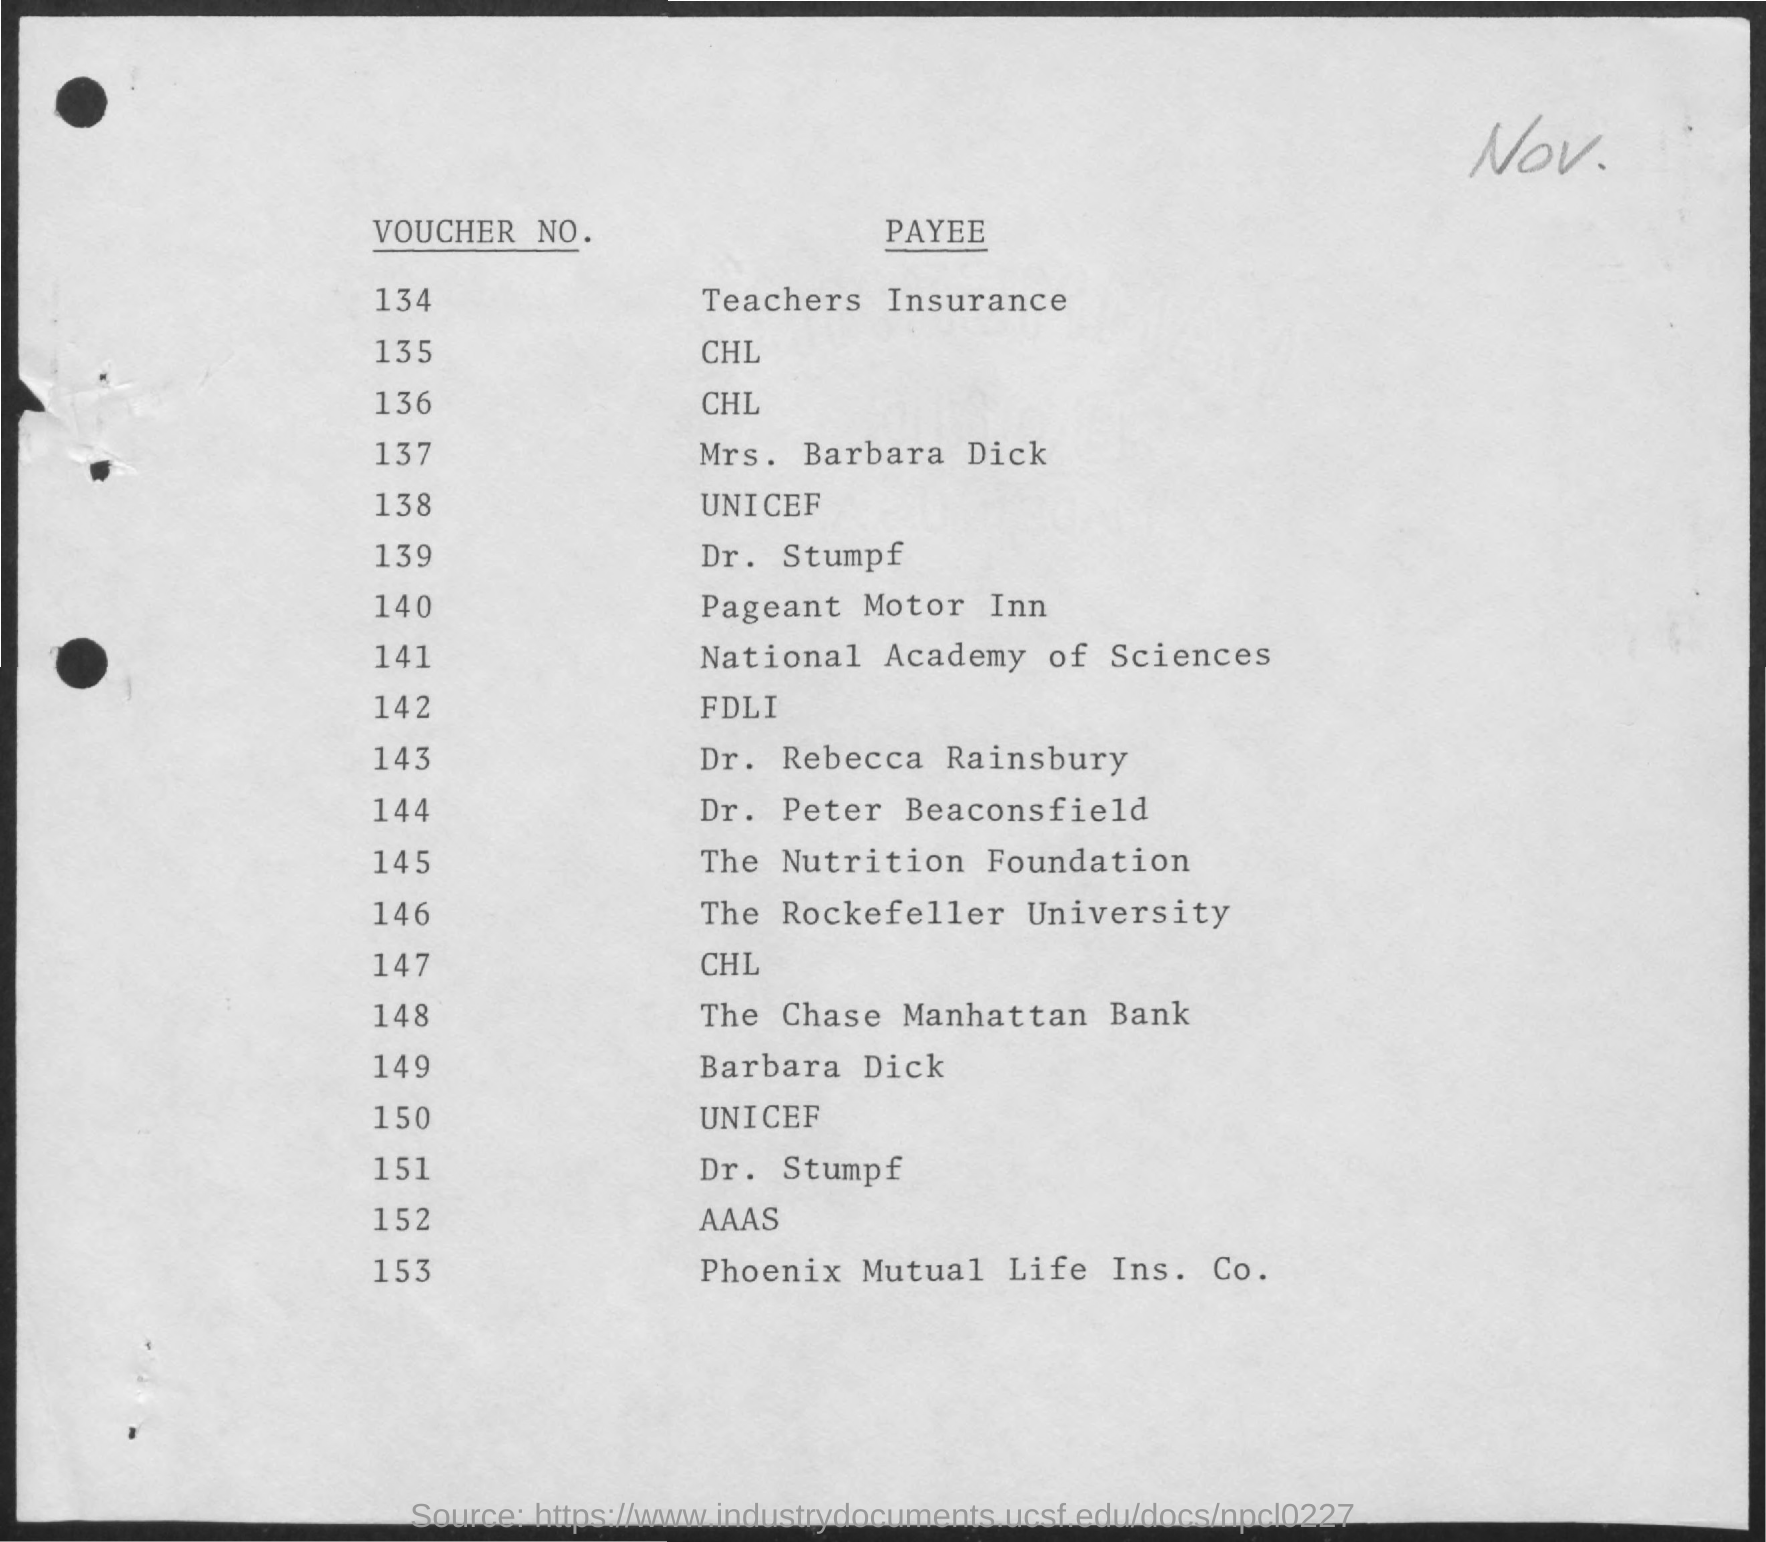Indicate a few pertinent items in this graphic. The voucher number for teachers' insurance is 134. The payee listed as "Phoenix Mutual Life Ins. Co." is the last person to receive a voucher. 